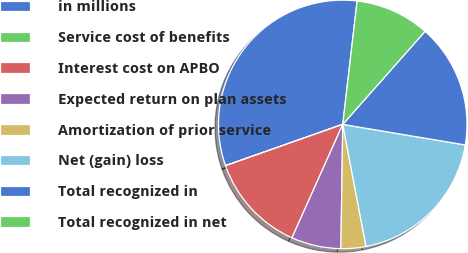Convert chart to OTSL. <chart><loc_0><loc_0><loc_500><loc_500><pie_chart><fcel>in millions<fcel>Service cost of benefits<fcel>Interest cost on APBO<fcel>Expected return on plan assets<fcel>Amortization of prior service<fcel>Net (gain) loss<fcel>Total recognized in<fcel>Total recognized in net<nl><fcel>32.23%<fcel>0.02%<fcel>12.9%<fcel>6.46%<fcel>3.24%<fcel>19.35%<fcel>16.12%<fcel>9.68%<nl></chart> 